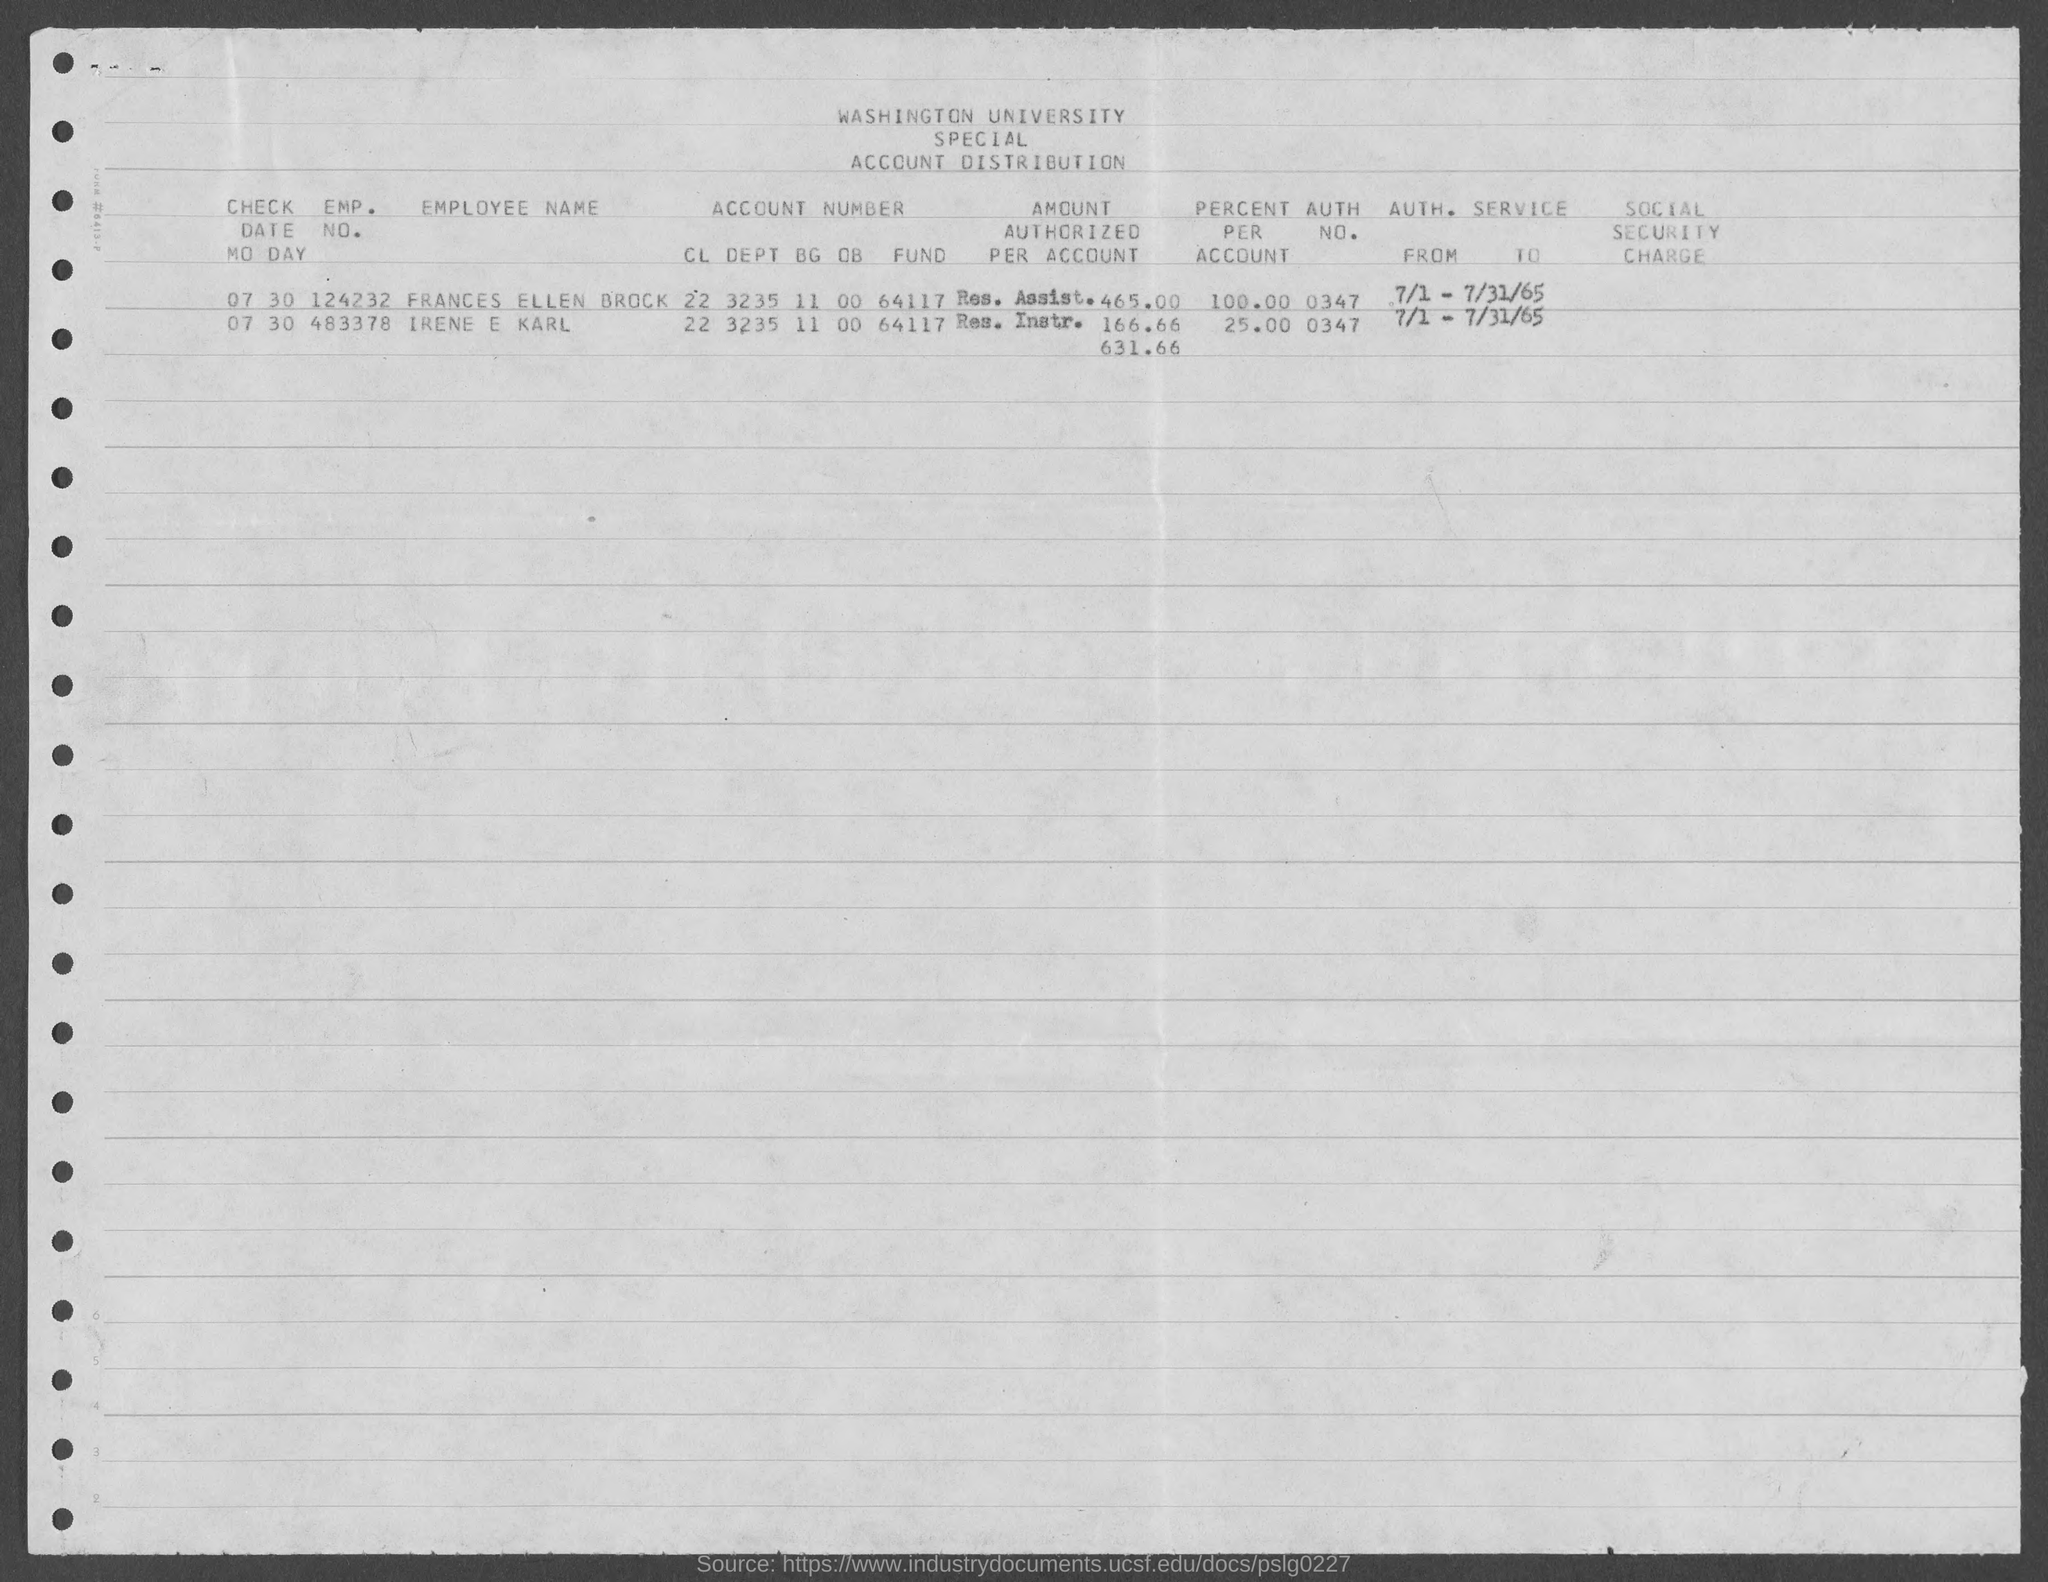Outline some significant characteristics in this image. The value of the percent per account for Frances Ellen Brock, as mentioned in the given form, is 100%. What is the author number for Frances Ellen Brock mentioned in the given page? It is 0347... The given text appears to be a question asking for the employment number of a person named Frances Ellen Brock, as mentioned in a form. However, without more context or information about the form in question, it is not possible to accurately determine the answer to this question. The value of the percentage for each account, as mentioned in the given form, is 25% for Irene and Karl. The emp. no. of Irene e Karl, as mentioned in the given form, is 483378... 